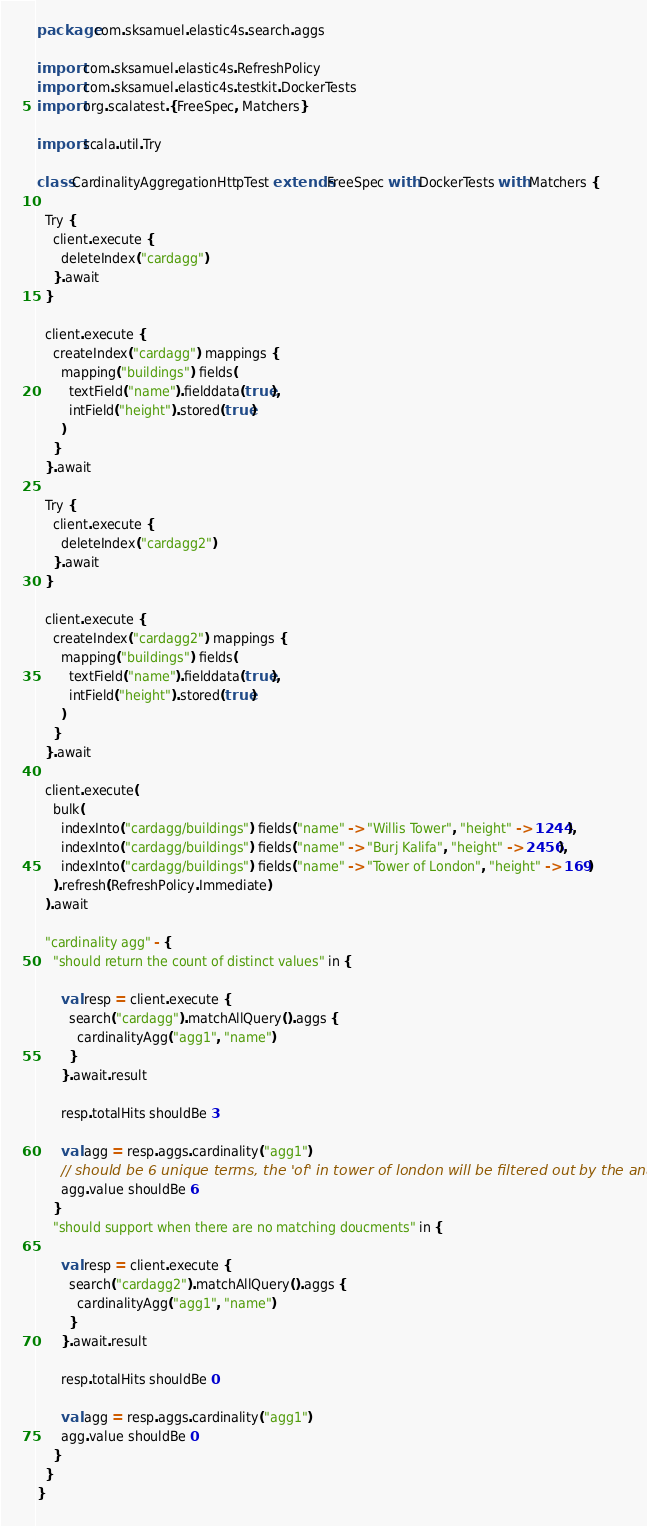<code> <loc_0><loc_0><loc_500><loc_500><_Scala_>package com.sksamuel.elastic4s.search.aggs

import com.sksamuel.elastic4s.RefreshPolicy
import com.sksamuel.elastic4s.testkit.DockerTests
import org.scalatest.{FreeSpec, Matchers}

import scala.util.Try

class CardinalityAggregationHttpTest extends FreeSpec with DockerTests with Matchers {

  Try {
    client.execute {
      deleteIndex("cardagg")
    }.await
  }

  client.execute {
    createIndex("cardagg") mappings {
      mapping("buildings") fields(
        textField("name").fielddata(true),
        intField("height").stored(true)
      )
    }
  }.await

  Try {
    client.execute {
      deleteIndex("cardagg2")
    }.await
  }

  client.execute {
    createIndex("cardagg2") mappings {
      mapping("buildings") fields(
        textField("name").fielddata(true),
        intField("height").stored(true)
      )
    }
  }.await

  client.execute(
    bulk(
      indexInto("cardagg/buildings") fields("name" -> "Willis Tower", "height" -> 1244),
      indexInto("cardagg/buildings") fields("name" -> "Burj Kalifa", "height" -> 2456),
      indexInto("cardagg/buildings") fields("name" -> "Tower of London", "height" -> 169)
    ).refresh(RefreshPolicy.Immediate)
  ).await

  "cardinality agg" - {
    "should return the count of distinct values" in {

      val resp = client.execute {
        search("cardagg").matchAllQuery().aggs {
          cardinalityAgg("agg1", "name")
        }
      }.await.result

      resp.totalHits shouldBe 3

      val agg = resp.aggs.cardinality("agg1")
      // should be 6 unique terms, the 'of' in tower of london will be filtered out by the analyzer
      agg.value shouldBe 6
    }
    "should support when there are no matching doucments" in {

      val resp = client.execute {
        search("cardagg2").matchAllQuery().aggs {
          cardinalityAgg("agg1", "name")
        }
      }.await.result

      resp.totalHits shouldBe 0

      val agg = resp.aggs.cardinality("agg1")
      agg.value shouldBe 0
    }
  }
}
</code> 